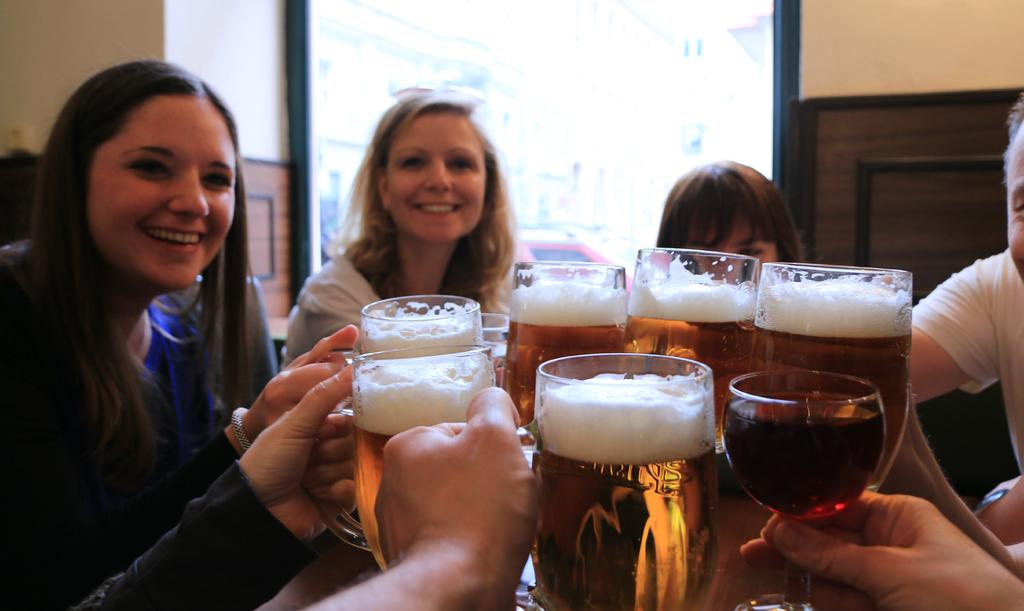What are the people in the image doing? The people in the image are sitting on a table and clinking their glasses together. Can you describe the background of the image? There is a glass door in the background of the image. What type of temper does the kettle have in the image? There is no kettle present in the image, so it is not possible to determine its temper. 